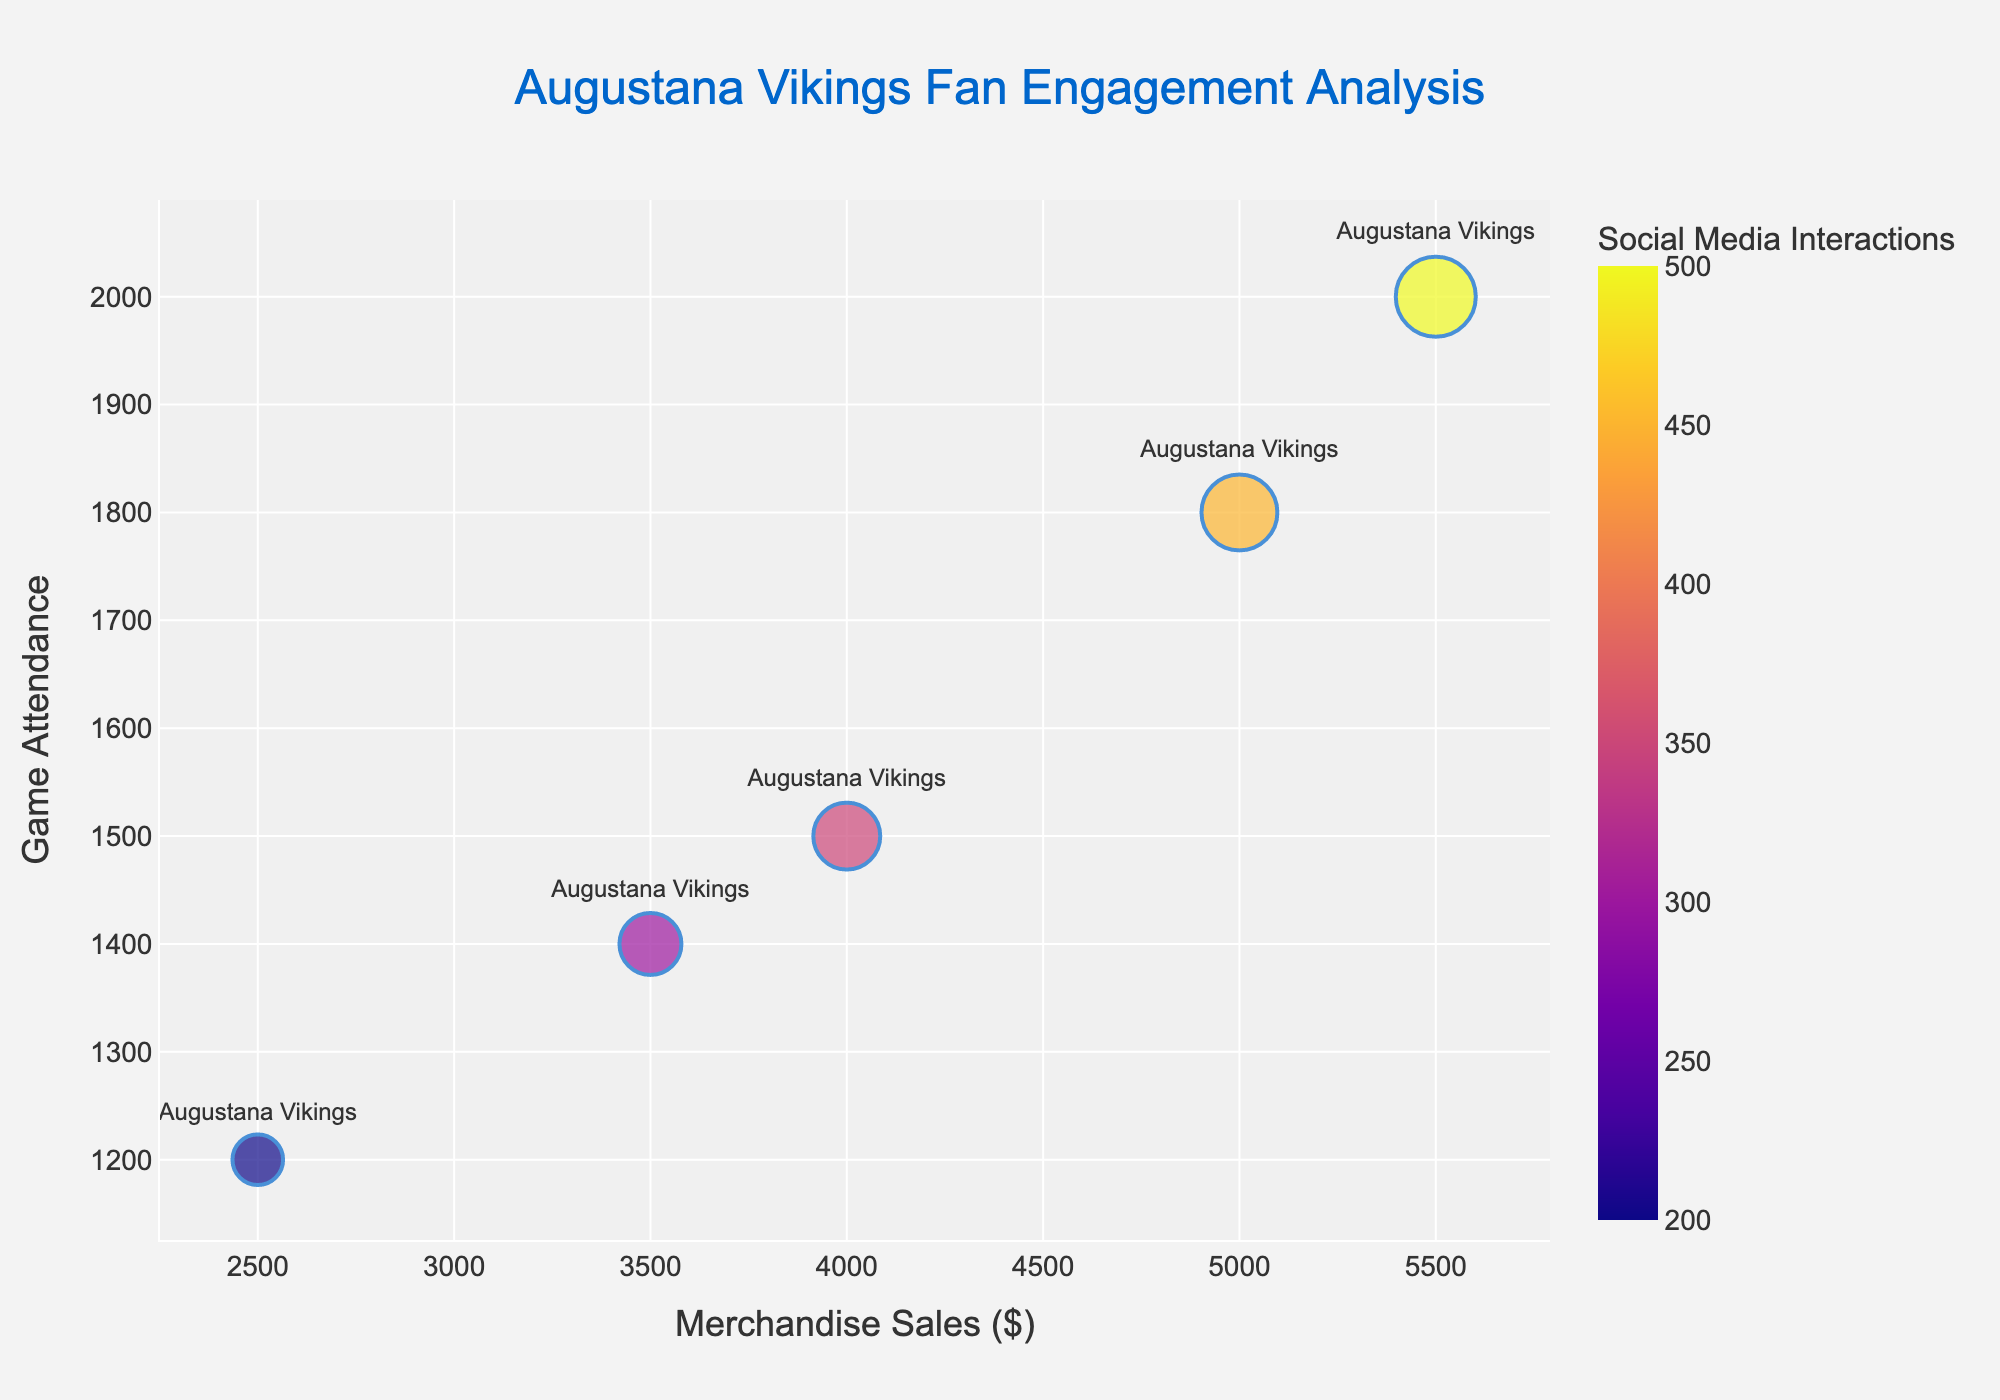What is the title of the chart? The title is usually prominently displayed at the top of the chart. In this case, it is a summary of the main subjects of the chart.
Answer: Augustana Vikings Fan Engagement Analysis What do the x and y axes represent? The x-axis and y-axis typically have titles that indicate what variables they are showing. Here, the x-axis title is 'Merchandise Sales ($)', and the y-axis title is 'Game Attendance'.
Answer: Merchandise Sales ($) and Game Attendance How many data points are displayed on the chart? By counting the number of bubbles on the chart, each representing a data point, we can determine the total number of points. The dataset provides 5 data points.
Answer: 5 Which data point has the largest bubble and what does it represent? The size of the bubble correlates with 'Social Media Interactions'. The largest bubble represents the highest value in 'Social Media Interactions' column.
Answer: The data point with 500 Social Media Interactions What is the general trend between merchandise sales and game attendance? By observing the slope direction of the data points in the chart, the relationship between the x and y variables could be identified. Here, higher merchandise sales are associated with higher game attendance.
Answer: Positive correlation For the game attendance of 1500, what are the merchandise sales and social media interactions? Locate the point on the y-axis corresponding to 'Game Attendance' of 1500 and observe its coordinates on the x-axis and bubble size.
Answer: Merchandise sales are 4000 and social media interactions are 350 Which data point has the highest game attendance, and what is its corresponding merchandise sales? Look for the highest value on the y-axis and then check the corresponding x-axis value for that point. The bubble size will confirm the specific data point based on hover or labeling.
Answer: Game attendance is 2000, and merchandise sales are 5500 Compare the social media interactions between data points with merchandise sales of 2500 and 5000. Locate both data points on the x-axis (2500 and 5000) and compare the bubble sizes to see which one is larger, representing higher social media interactions.
Answer: 2500 has 200 social media interactions, and 5000 has 450 What can be inferred if a bubble has a high opacity but is relatively small in size? High opacity indicates a strong weight in 'Social Media Interactions', and a small size means fewer interactions, suggesting it is impactful but with lower engagement compared to larger bubbles.
Answer: Fewer social media interactions, indicating lower engagement Which specific data point has both the highest merchandise sales and highest social media interactions? The data point that is farthest right on the x-axis and has the largest bubble size should be checked for these two highest values.
Answer: Merchandise sales are 5500, and social media interactions are 500 